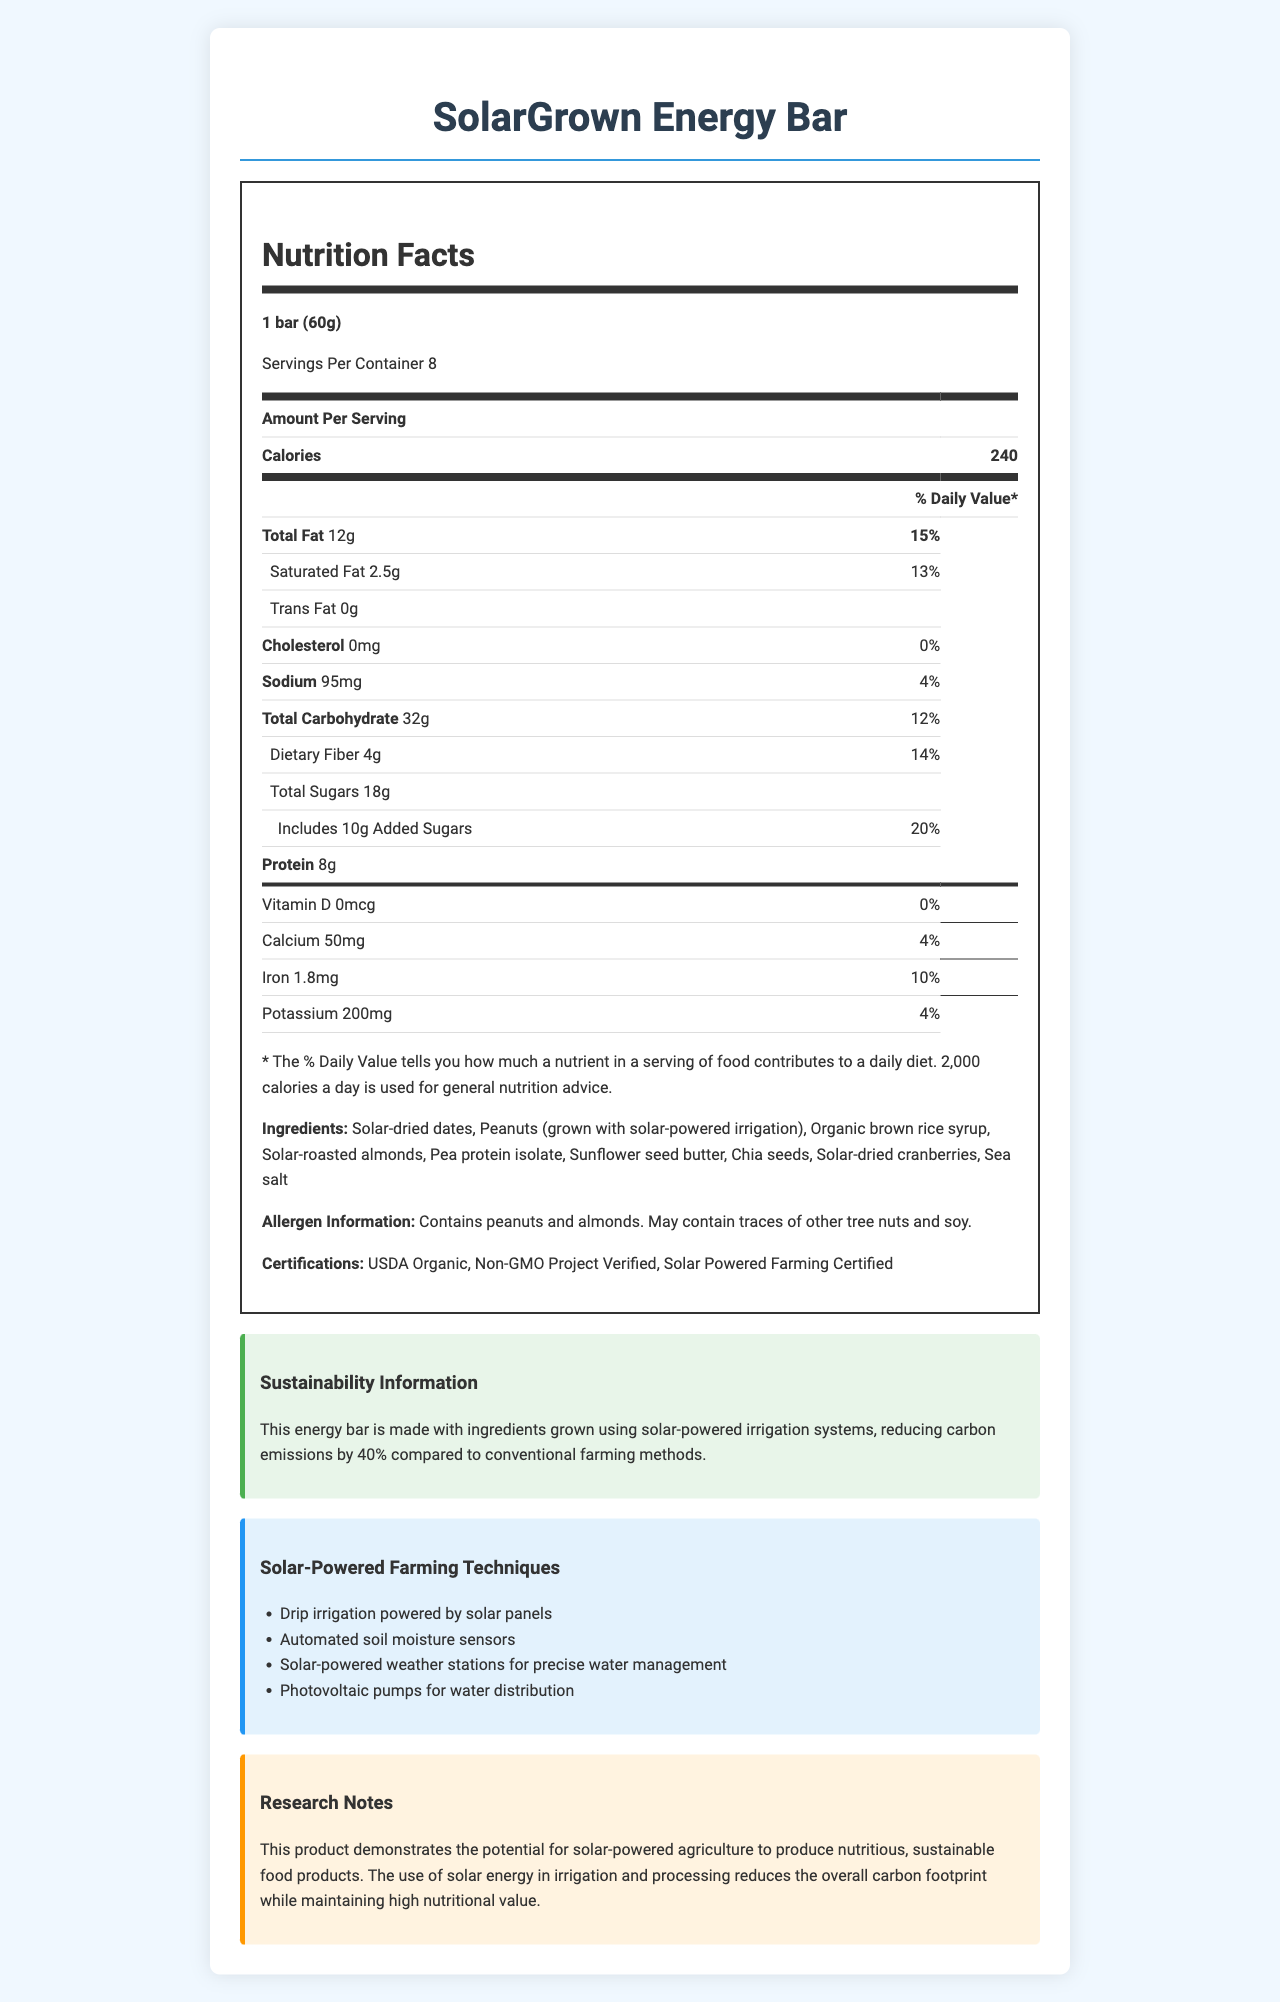what is the serving size for a SolarGrown Energy Bar? The serving size is explicitly mentioned as "1 bar (60g)" under the Nutrition Facts section.
Answer: 1 bar (60g) how much protein does one bar contain? The protein content is listed under the nutrition label with "Protein 8g".
Answer: 8g what is the % Daily Value for dietary fiber? Under the dietary fiber section, it's mentioned as "Dietary Fiber 4g" with "Daily Value 14%".
Answer: 14% what are the first three ingredients listed for the SolarGrown Energy Bar? The ingredients are listed in a specific order starting with "Solar-dried dates, Peanuts (grown with solar-powered irrigation), Organic brown rice syrup".
Answer: Solar-dried dates, Peanuts (grown with solar-powered irrigation), Organic brown rice syrup how many calories are in one bar? The calorie content is given under "Calories" in the Nutrition Facts section and is stated as "240".
Answer: 240 which certification confirms that the products were grown using solar-powered methods? A. USDA Organic B. Non-GMO Project Verified C. Solar Powered Farming Certified The "Solar Powered Farming Certified" certification confirms the use of solar-powered methods.
Answer: C what farming technique uses solar power for automated water management? A. Drip irrigation powered by solar panels B. Automated soil moisture sensors C. Photovoltaic pumps for water distribution The "Automated soil moisture sensors" utilize solar power for automated water management.
Answer: B does the SolarGrown Energy Bar contain any cholesterol? The document states "Cholesterol 0mg" under the nutrition section.
Answer: No are there any traces of soy in the SolarGrown Energy Bar? The allergen information section mentions "May contain traces of other tree nuts and soy."
Answer: Yes summarize the main idea of the document. The document emphasizes the nutritional benefits, sustainable farming methods, and certifications associated with the SolarGrown Energy Bar, highlighting its reduced carbon footprint and high nutritional value.
Answer: The document details the Nutrition Facts of the SolarGrown Energy Bar, which is made with ingredients grown using solar-powered irrigation systems. It provides information on serving size, calorie content, various nutrients, ingredients, allergen information, certifications, sustainability practices, and research notes on the impact of solar-powered farming techniques. what is the reduction in carbon emissions due to using solar-powered irrigation systems? The sustainability information section states "reducing carbon emissions by 40% compared to conventional farming methods."
Answer: 40% who is the primary manufacturer of the SolarGrown Energy Bar? The document does not provide information regarding the manufacturer of the SolarGrown Energy Bar.
Answer: Not enough information 